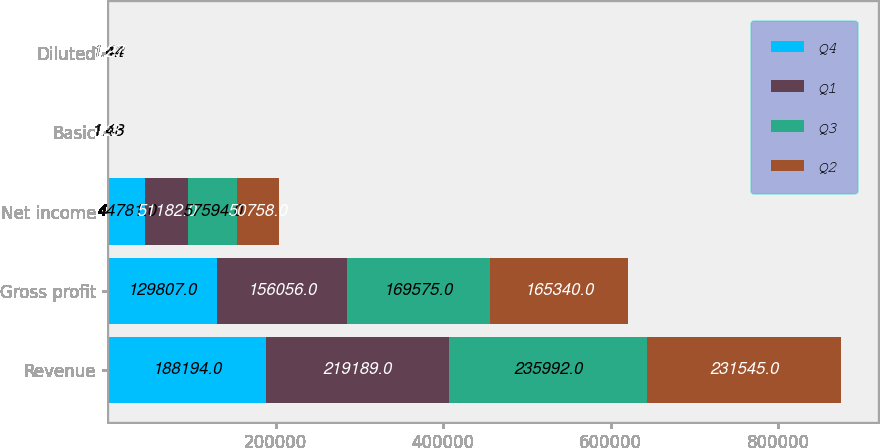Convert chart to OTSL. <chart><loc_0><loc_0><loc_500><loc_500><stacked_bar_chart><ecel><fcel>Revenue<fcel>Gross profit<fcel>Net income<fcel>Basic<fcel>Diluted<nl><fcel>Q4<fcel>188194<fcel>129807<fcel>44781<fcel>1.16<fcel>1.12<nl><fcel>Q1<fcel>219189<fcel>156056<fcel>51182<fcel>1.32<fcel>1.28<nl><fcel>Q3<fcel>235992<fcel>169575<fcel>57594<fcel>1.48<fcel>1.44<nl><fcel>Q2<fcel>231545<fcel>165340<fcel>50758<fcel>1.3<fcel>1.27<nl></chart> 